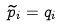Convert formula to latex. <formula><loc_0><loc_0><loc_500><loc_500>\widetilde { p } _ { i } = q _ { i }</formula> 